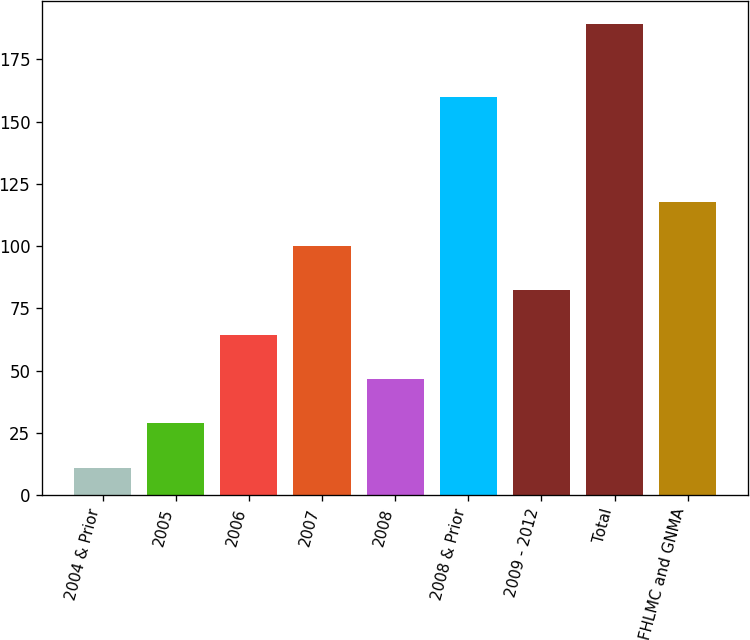Convert chart to OTSL. <chart><loc_0><loc_0><loc_500><loc_500><bar_chart><fcel>2004 & Prior<fcel>2005<fcel>2006<fcel>2007<fcel>2008<fcel>2008 & Prior<fcel>2009 - 2012<fcel>Total<fcel>FNMA FHLMC and GNMA<nl><fcel>11<fcel>28.8<fcel>64.4<fcel>100<fcel>46.6<fcel>160<fcel>82.2<fcel>189<fcel>117.8<nl></chart> 